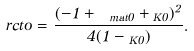Convert formula to latex. <formula><loc_0><loc_0><loc_500><loc_500>\Omega _ { \ } r c t o = \frac { ( - 1 + \Omega _ { \ m a t 0 } + \Omega _ { K 0 } ) ^ { 2 } } { 4 ( 1 - \Omega _ { K 0 } ) } .</formula> 